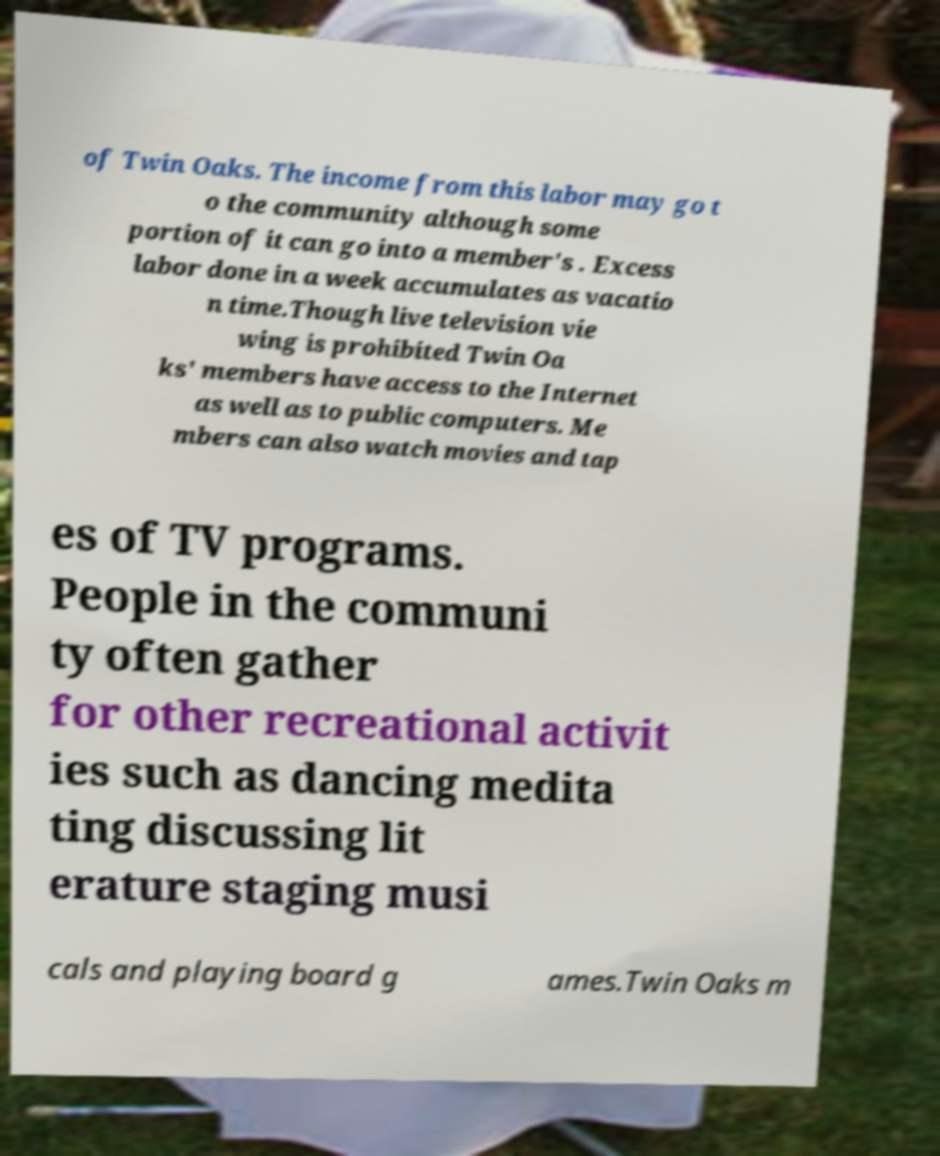Could you extract and type out the text from this image? of Twin Oaks. The income from this labor may go t o the community although some portion of it can go into a member's . Excess labor done in a week accumulates as vacatio n time.Though live television vie wing is prohibited Twin Oa ks' members have access to the Internet as well as to public computers. Me mbers can also watch movies and tap es of TV programs. People in the communi ty often gather for other recreational activit ies such as dancing medita ting discussing lit erature staging musi cals and playing board g ames.Twin Oaks m 